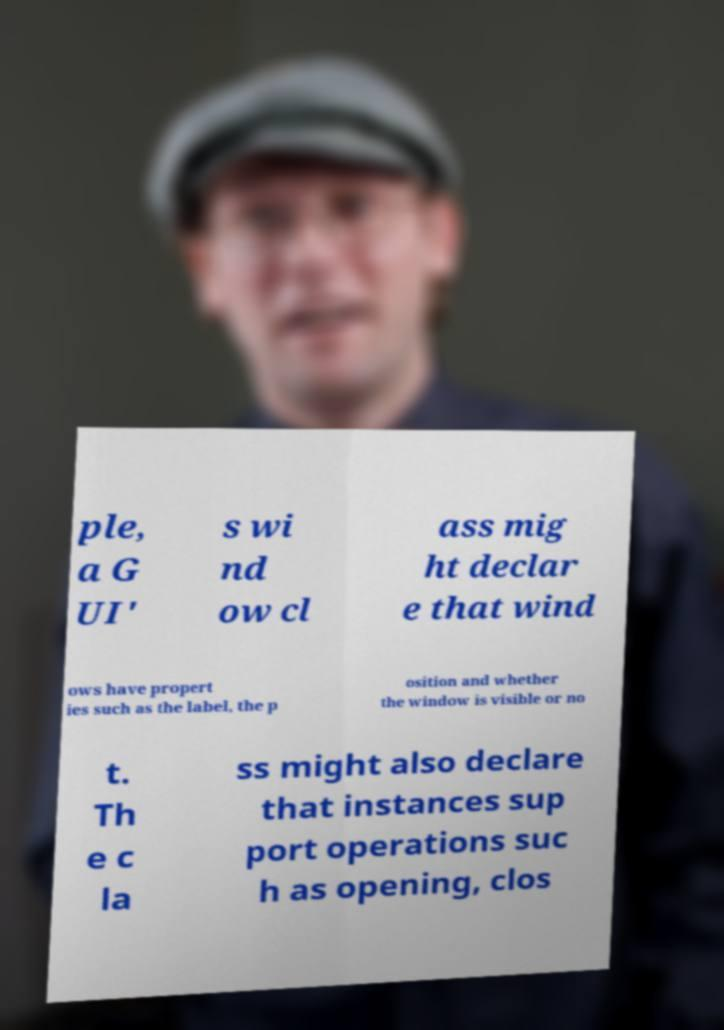Please identify and transcribe the text found in this image. ple, a G UI' s wi nd ow cl ass mig ht declar e that wind ows have propert ies such as the label, the p osition and whether the window is visible or no t. Th e c la ss might also declare that instances sup port operations suc h as opening, clos 